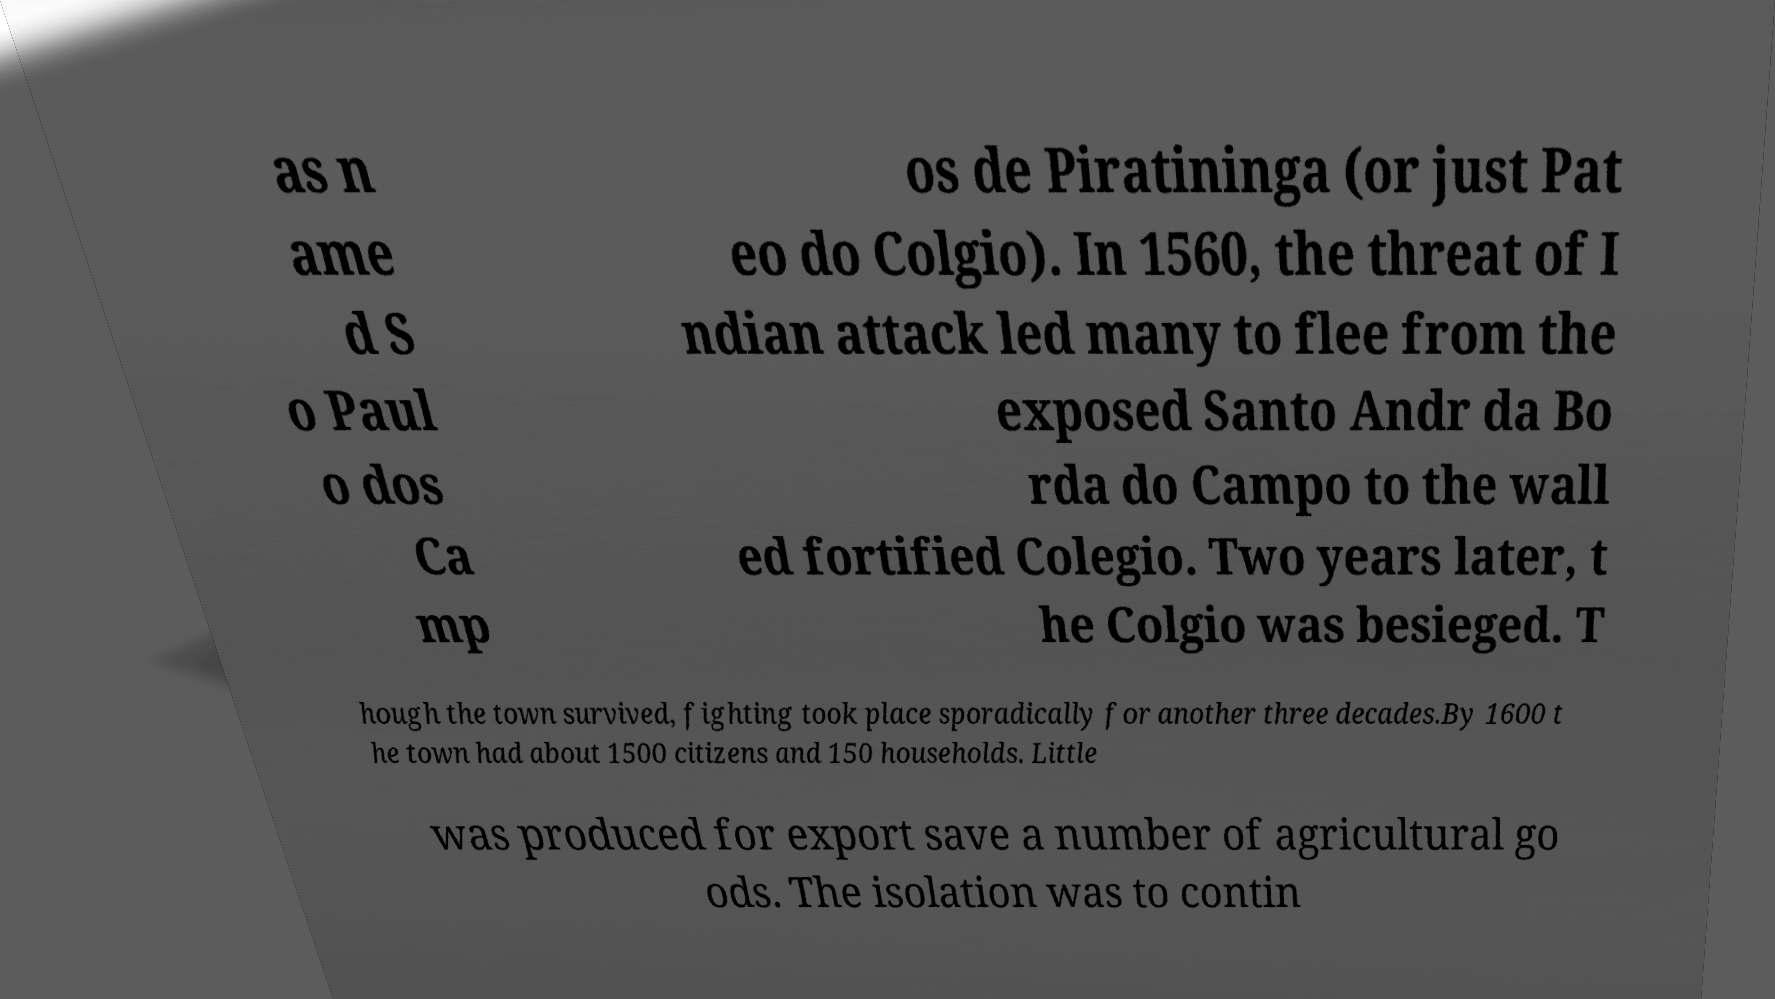Can you read and provide the text displayed in the image?This photo seems to have some interesting text. Can you extract and type it out for me? as n ame d S o Paul o dos Ca mp os de Piratininga (or just Pat eo do Colgio). In 1560, the threat of I ndian attack led many to flee from the exposed Santo Andr da Bo rda do Campo to the wall ed fortified Colegio. Two years later, t he Colgio was besieged. T hough the town survived, fighting took place sporadically for another three decades.By 1600 t he town had about 1500 citizens and 150 households. Little was produced for export save a number of agricultural go ods. The isolation was to contin 